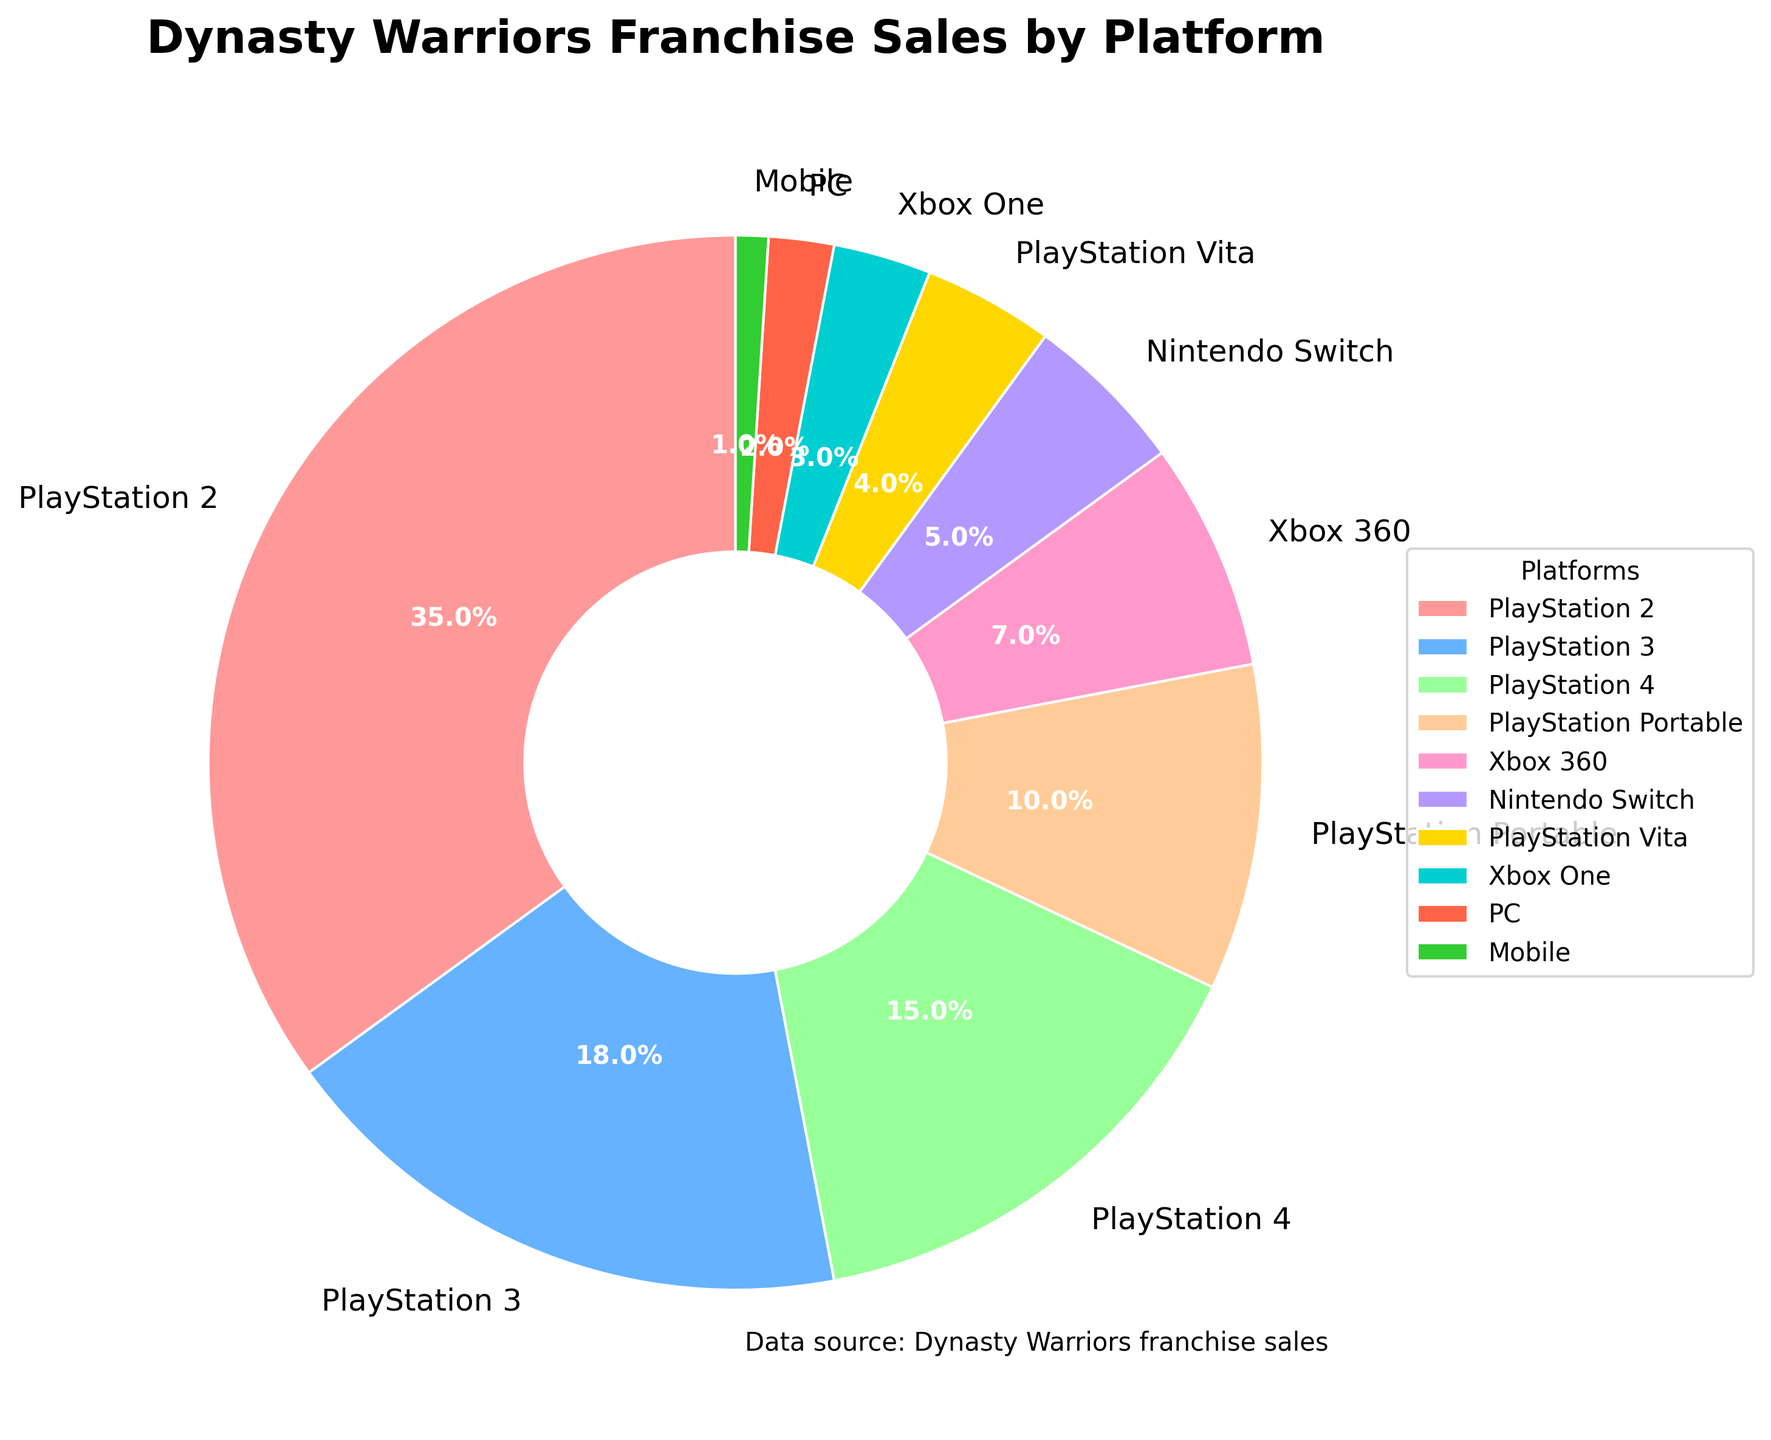Which platform has the highest sales percentage? By looking at the wedge sizes and the percentage labels in the pie chart, the PlayStation 2 section is the largest, indicating the highest sales percentage.
Answer: PlayStation 2 How much larger is the sales percentage of PlayStation 2 compared to the Xbox 360? The wedge for PlayStation 2 is labeled 35% and the wedge for Xbox 360 is labeled 7%. Subtracting these values, 35% - 7% = 28%.
Answer: 28% What is the combined sales percentage of PlayStation 3 and PlayStation 4? The wedges for PlayStation 3 and PlayStation 4 are labeled 18% and 15%, respectively. Summing these values, 18% + 15% = 33%.
Answer: 33% Which platform has the smallest sales percentage? By examining the size of the wedges and the percentage labels, the Mobile section is the smallest, indicating the lowest sales percentage at 1%.
Answer: Mobile Is the sales percentage of the PlayStation Portable greater than that of Xbox One? By how much? The wedge for PlayStation Portable is labeled 10%, and the Xbox One wedge is labeled 3%. Subtracting these values, 10% - 3% = 7%.
Answer: 7% How many platforms have a sales percentage less than 5%? By checking the percentage labels, four platforms have sales percentages less than 5%: PlayStation Vita (4%), Xbox One (3%), PC (2%), and Mobile (1%).
Answer: 4 What is the total sales percentage for all Xbox platforms combined? The wedges for Xbox 360 and Xbox One are labeled 7% and 3%, respectively. Summing these values, 7% + 3% = 10%.
Answer: 10% Which platform has the third-largest sales percentage, and what is it? By comparing the wedge sizes and labels, the platform with the third-largest sales percentage is PlayStation 4 at 15%.
Answer: PlayStation 4, 15% What is the difference in sales percentage between PlayStation 3 and Nintendo Switch? The wedge for PlayStation 3 is labeled 18% and the Nintendo Switch wedge is labeled 5%. Subtracting these values, 18% - 5% = 13%.
Answer: 13% If you sum the sales percentages for all PlayStation platforms, what do you get? Summing the percentages for PlayStation 2 (35%), PlayStation 3 (18%), PlayStation 4 (15%), PlayStation Portable (10%), and PlayStation Vita (4%) gives 35% + 18% + 15% + 10% + 4% = 82%.
Answer: 82% 